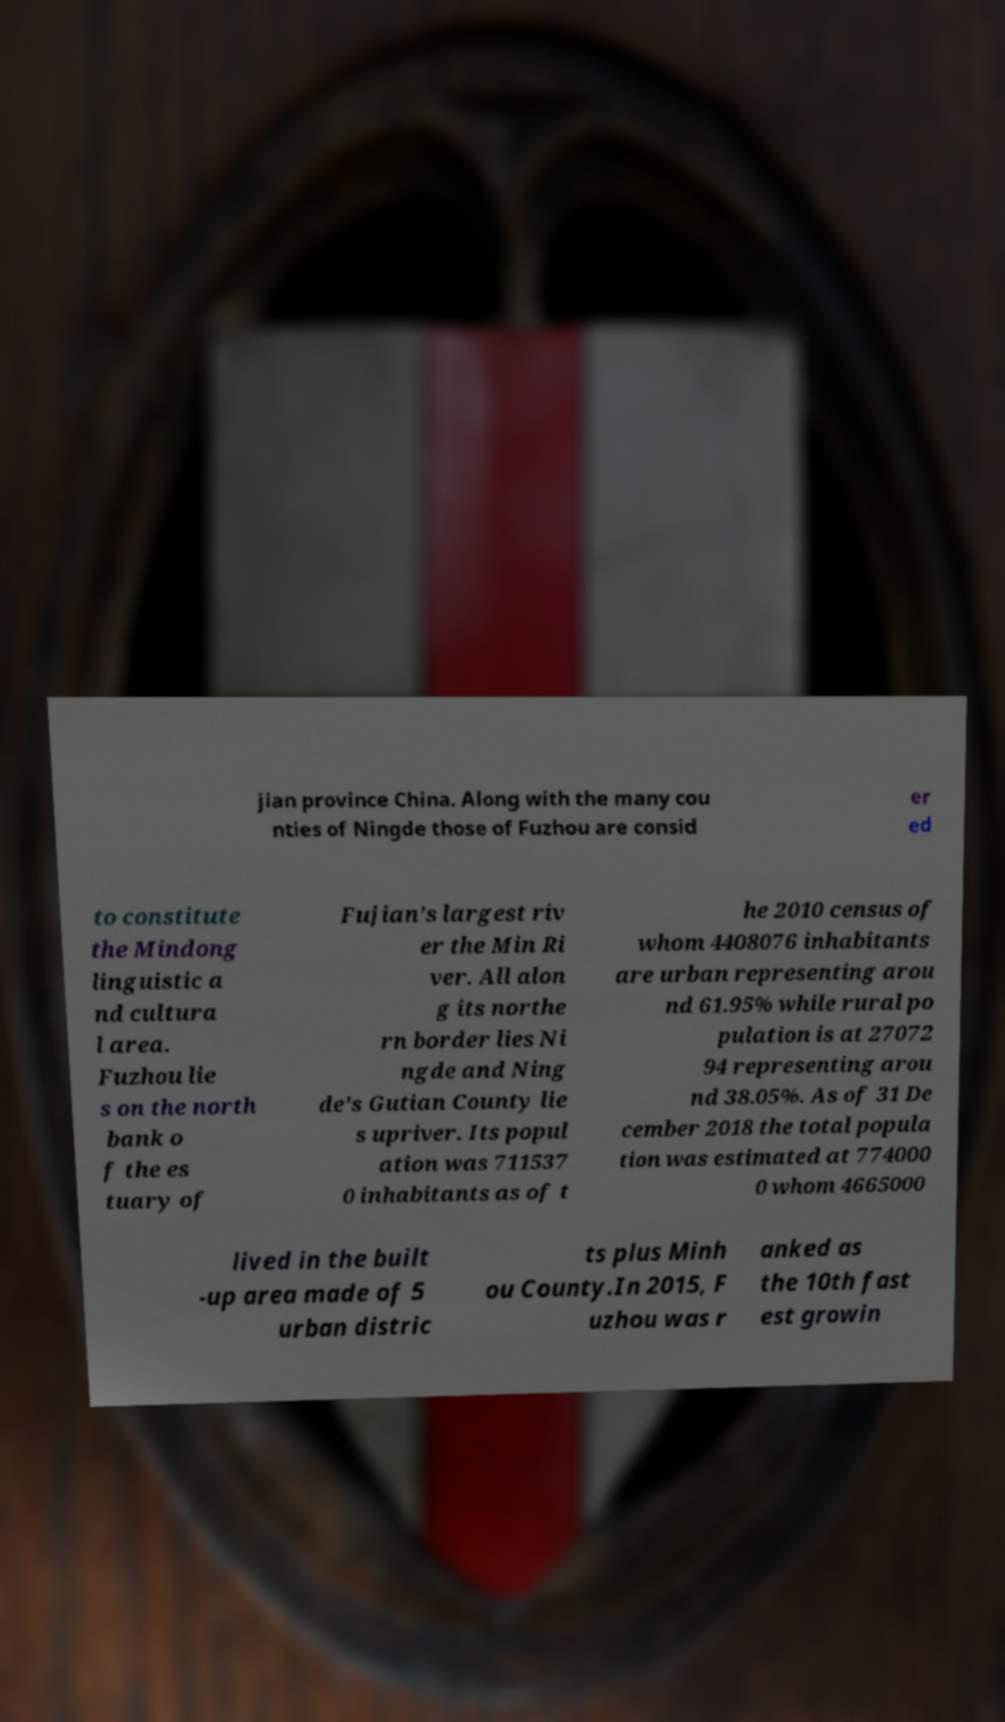There's text embedded in this image that I need extracted. Can you transcribe it verbatim? jian province China. Along with the many cou nties of Ningde those of Fuzhou are consid er ed to constitute the Mindong linguistic a nd cultura l area. Fuzhou lie s on the north bank o f the es tuary of Fujian's largest riv er the Min Ri ver. All alon g its northe rn border lies Ni ngde and Ning de's Gutian County lie s upriver. Its popul ation was 711537 0 inhabitants as of t he 2010 census of whom 4408076 inhabitants are urban representing arou nd 61.95% while rural po pulation is at 27072 94 representing arou nd 38.05%. As of 31 De cember 2018 the total popula tion was estimated at 774000 0 whom 4665000 lived in the built -up area made of 5 urban distric ts plus Minh ou County.In 2015, F uzhou was r anked as the 10th fast est growin 